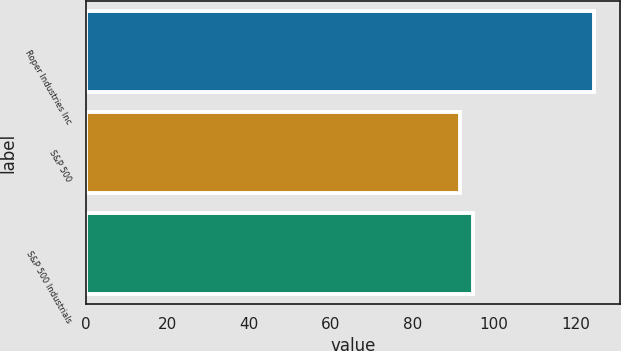Convert chart. <chart><loc_0><loc_0><loc_500><loc_500><bar_chart><fcel>Roper Industries Inc<fcel>S&P 500<fcel>S&P 500 Industrials<nl><fcel>124.61<fcel>91.67<fcel>94.96<nl></chart> 